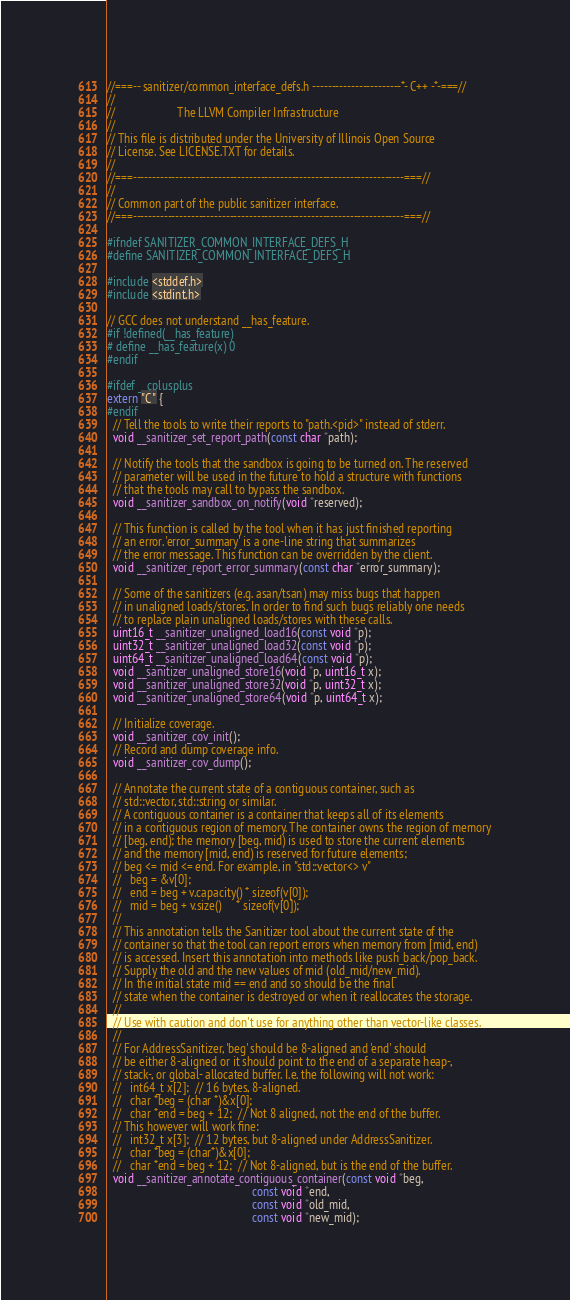<code> <loc_0><loc_0><loc_500><loc_500><_C_>//===-- sanitizer/common_interface_defs.h -----------------------*- C++ -*-===//
//
//                     The LLVM Compiler Infrastructure
//
// This file is distributed under the University of Illinois Open Source
// License. See LICENSE.TXT for details.
//
//===----------------------------------------------------------------------===//
//
// Common part of the public sanitizer interface.
//===----------------------------------------------------------------------===//

#ifndef SANITIZER_COMMON_INTERFACE_DEFS_H
#define SANITIZER_COMMON_INTERFACE_DEFS_H

#include <stddef.h>
#include <stdint.h>

// GCC does not understand __has_feature.
#if !defined(__has_feature)
# define __has_feature(x) 0
#endif

#ifdef __cplusplus
extern "C" {
#endif
  // Tell the tools to write their reports to "path.<pid>" instead of stderr.
  void __sanitizer_set_report_path(const char *path);

  // Notify the tools that the sandbox is going to be turned on. The reserved
  // parameter will be used in the future to hold a structure with functions
  // that the tools may call to bypass the sandbox.
  void __sanitizer_sandbox_on_notify(void *reserved);

  // This function is called by the tool when it has just finished reporting
  // an error. 'error_summary' is a one-line string that summarizes
  // the error message. This function can be overridden by the client.
  void __sanitizer_report_error_summary(const char *error_summary);

  // Some of the sanitizers (e.g. asan/tsan) may miss bugs that happen
  // in unaligned loads/stores. In order to find such bugs reliably one needs
  // to replace plain unaligned loads/stores with these calls.
  uint16_t __sanitizer_unaligned_load16(const void *p);
  uint32_t __sanitizer_unaligned_load32(const void *p);
  uint64_t __sanitizer_unaligned_load64(const void *p);
  void __sanitizer_unaligned_store16(void *p, uint16_t x);
  void __sanitizer_unaligned_store32(void *p, uint32_t x);
  void __sanitizer_unaligned_store64(void *p, uint64_t x);

  // Initialize coverage.
  void __sanitizer_cov_init();
  // Record and dump coverage info.
  void __sanitizer_cov_dump();

  // Annotate the current state of a contiguous container, such as
  // std::vector, std::string or similar.
  // A contiguous container is a container that keeps all of its elements
  // in a contiguous region of memory. The container owns the region of memory
  // [beg, end); the memory [beg, mid) is used to store the current elements
  // and the memory [mid, end) is reserved for future elements;
  // beg <= mid <= end. For example, in "std::vector<> v"
  //   beg = &v[0];
  //   end = beg + v.capacity() * sizeof(v[0]);
  //   mid = beg + v.size()     * sizeof(v[0]);
  //
  // This annotation tells the Sanitizer tool about the current state of the
  // container so that the tool can report errors when memory from [mid, end)
  // is accessed. Insert this annotation into methods like push_back/pop_back.
  // Supply the old and the new values of mid (old_mid/new_mid).
  // In the initial state mid == end and so should be the final
  // state when the container is destroyed or when it reallocates the storage.
  //
  // Use with caution and don't use for anything other than vector-like classes.
  //
  // For AddressSanitizer, 'beg' should be 8-aligned and 'end' should
  // be either 8-aligned or it should point to the end of a separate heap-,
  // stack-, or global- allocated buffer. I.e. the following will not work:
  //   int64_t x[2];  // 16 bytes, 8-aligned.
  //   char *beg = (char *)&x[0];
  //   char *end = beg + 12;  // Not 8 aligned, not the end of the buffer.
  // This however will work fine:
  //   int32_t x[3];  // 12 bytes, but 8-aligned under AddressSanitizer.
  //   char *beg = (char*)&x[0];
  //   char *end = beg + 12;  // Not 8-aligned, but is the end of the buffer.
  void __sanitizer_annotate_contiguous_container(const void *beg,
                                                 const void *end,
                                                 const void *old_mid,
                                                 const void *new_mid);
</code> 